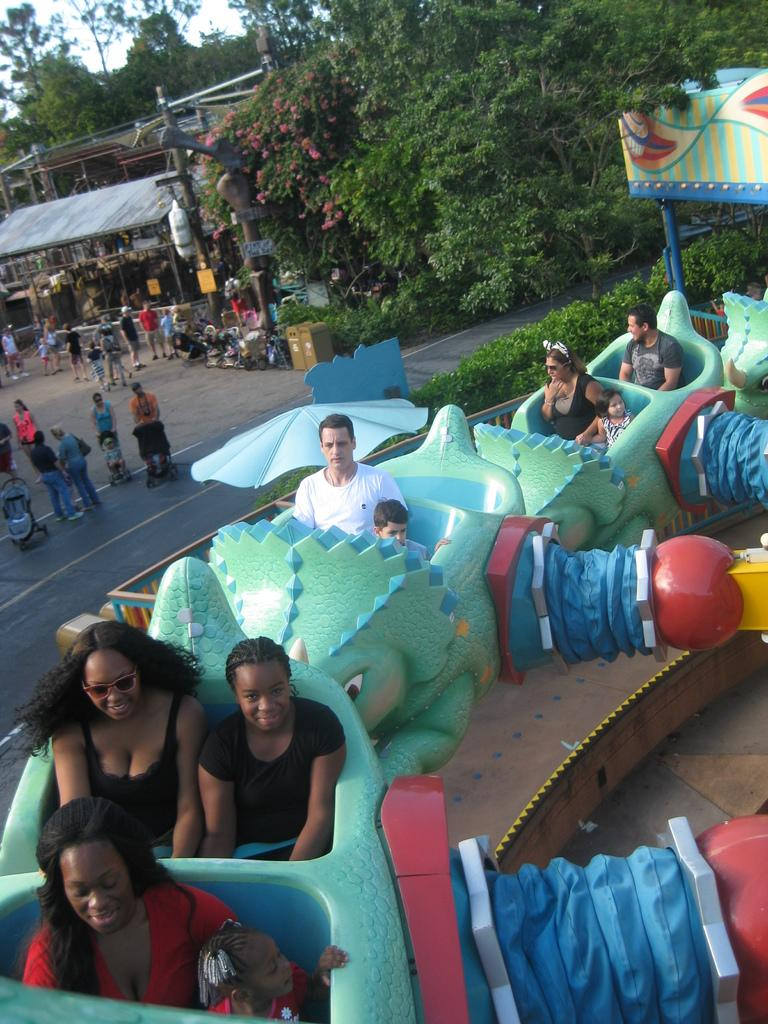What are the people in the image doing? The people in the image are sitting. Where are the people located in the image? The people are at the bottom of the image. How many people are in the image? There is a group of people in the image. What can be seen in the background of the image? There are trees and a shop in the background of the image. What type of knot is being used to secure the shop in the background of the image? There is no knot visible in the image, as it is a group of people sitting and a shop in the background. 